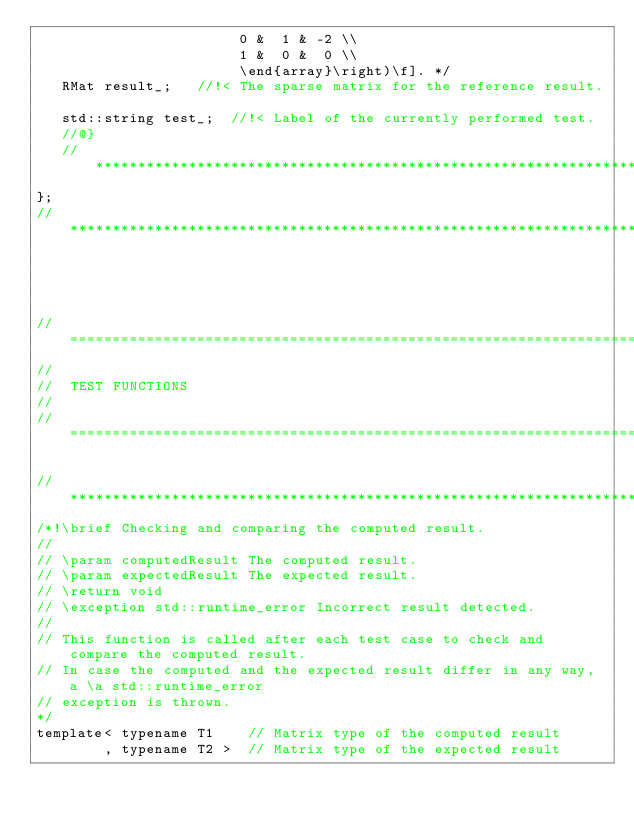Convert code to text. <code><loc_0><loc_0><loc_500><loc_500><_C_>                        0 &  1 & -2 \\
                        1 &  0 &  0 \\
                        \end{array}\right)\f]. */
   RMat result_;   //!< The sparse matrix for the reference result.

   std::string test_;  //!< Label of the currently performed test.
   //@}
   //**********************************************************************************************
};
//*************************************************************************************************




//=================================================================================================
//
//  TEST FUNCTIONS
//
//=================================================================================================

//*************************************************************************************************
/*!\brief Checking and comparing the computed result.
//
// \param computedResult The computed result.
// \param expectedResult The expected result.
// \return void
// \exception std::runtime_error Incorrect result detected.
//
// This function is called after each test case to check and compare the computed result.
// In case the computed and the expected result differ in any way, a \a std::runtime_error
// exception is thrown.
*/
template< typename T1    // Matrix type of the computed result
        , typename T2 >  // Matrix type of the expected result</code> 